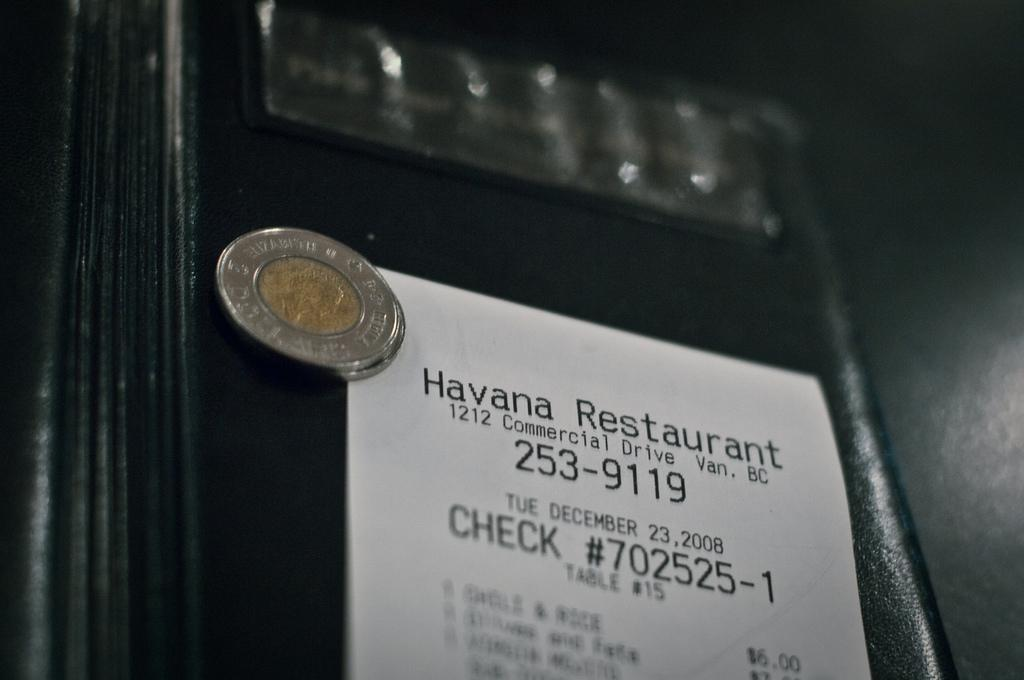Provide a one-sentence caption for the provided image. A coin sits on top of a receipt for the Havana restaurant. 